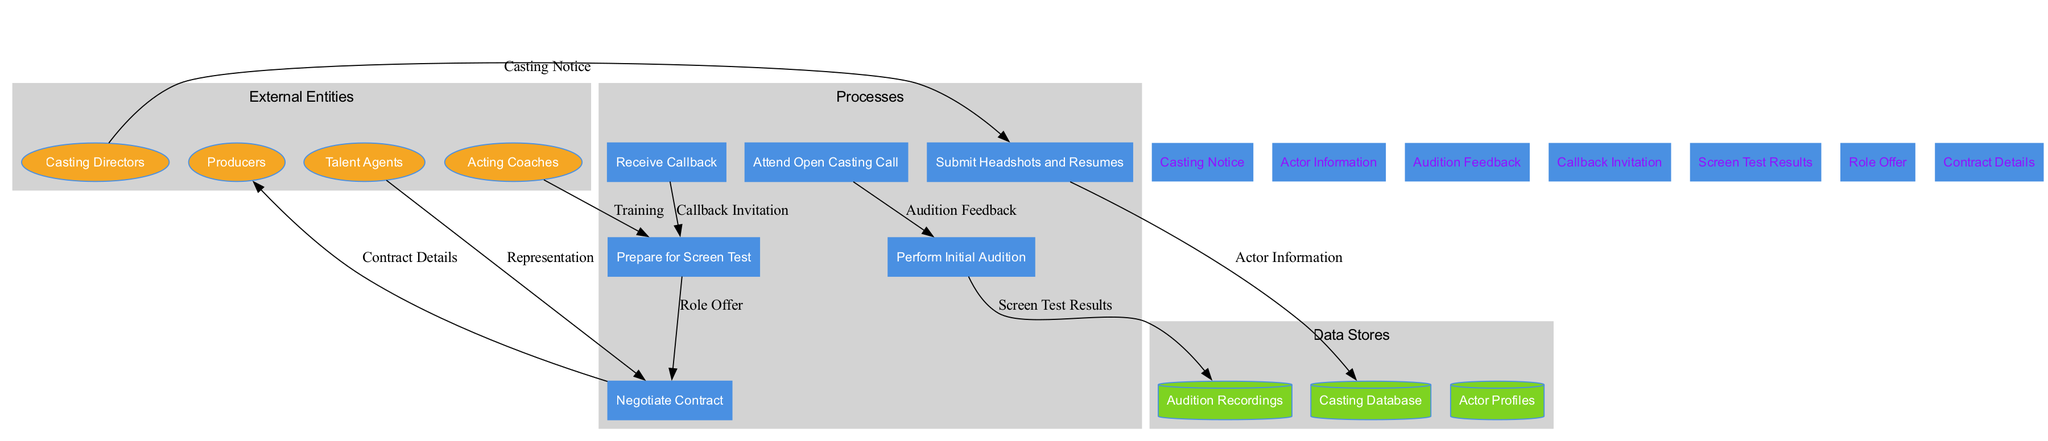What are the external entities involved in the casting process? The external entities are listed on the left side of the diagram, including Casting Directors, Talent Agents, Producers, and Acting Coaches.
Answer: Casting Directors, Talent Agents, Producers, Acting Coaches How many processes are illustrated in the diagram? By counting the rectangles in the processes section of the diagram, we find there are six processes: Submit Headshots and Resumes, Attend Open Casting Call, Perform Initial Audition, Receive Callback, Prepare for Screen Test, and Negotiate Contract.
Answer: Six What type of information is stored in the Casting Database? The arrow from the "Submit Headshots and Resumes" process to the "Casting Database" indicates that Actor Information is stored in this data store.
Answer: Actor Information What follows after receiving a callback? According to the flow of the diagram, after "Receive Callback," the next process is "Prepare for Screen Test."
Answer: Prepare for Screen Test How many data flows are represented in the diagram? There are seven data flows, as observed from the arrows connecting different entities and processes in the diagram. This includes flows like Casting Notice, Audition Feedback, and Role Offer.
Answer: Seven Which external entity is involved in preparing for the screen test? The diagram shows an arrow from "Acting Coaches" to "Prepare for Screen Test," indicating their involvement in this process.
Answer: Acting Coaches What is the final step in the audition process flow? The process "Negotiate Contract" is the last process before the final contract details are sent to Producers, marking the end of the audition flow.
Answer: Negotiate Contract What type of data store holds Audition Recordings? The cylinder labeled "Audition Recordings" within the data stores section specifically indicates this type of data storage related to auditions.
Answer: Audition Recordings How does Talent Agents contribute in the process flow? Talent Agents are linked to "Negotiate Contract," showing their role in representing actors during contract negotiations.
Answer: Negotiate Contract 